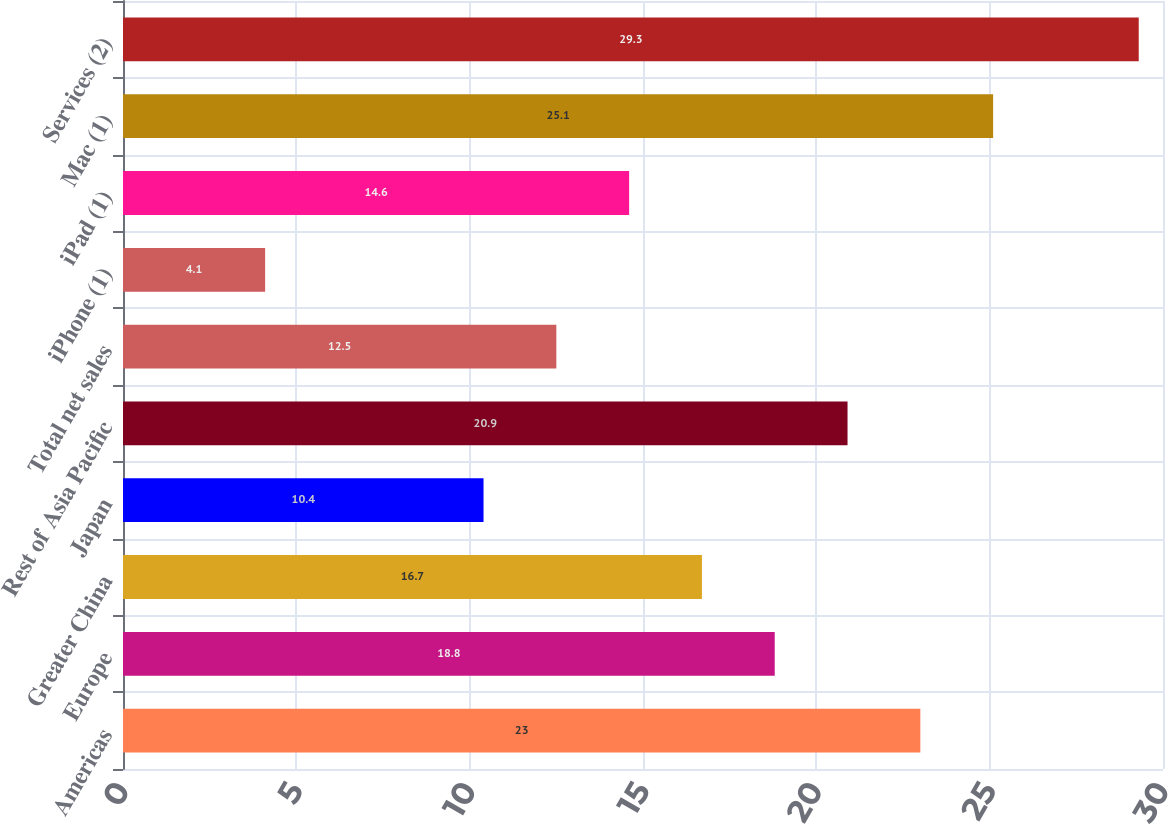Convert chart. <chart><loc_0><loc_0><loc_500><loc_500><bar_chart><fcel>Americas<fcel>Europe<fcel>Greater China<fcel>Japan<fcel>Rest of Asia Pacific<fcel>Total net sales<fcel>iPhone (1)<fcel>iPad (1)<fcel>Mac (1)<fcel>Services (2)<nl><fcel>23<fcel>18.8<fcel>16.7<fcel>10.4<fcel>20.9<fcel>12.5<fcel>4.1<fcel>14.6<fcel>25.1<fcel>29.3<nl></chart> 